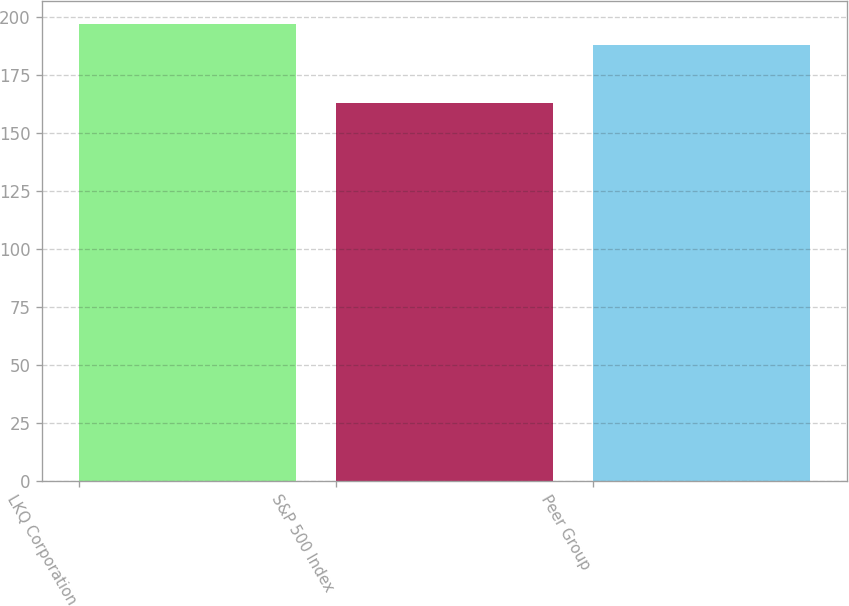Convert chart. <chart><loc_0><loc_0><loc_500><loc_500><bar_chart><fcel>LKQ Corporation<fcel>S&P 500 Index<fcel>Peer Group<nl><fcel>197<fcel>163<fcel>188<nl></chart> 